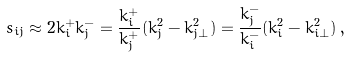<formula> <loc_0><loc_0><loc_500><loc_500>s _ { i j } \approx 2 k ^ { + } _ { i } k ^ { - } _ { j } = \frac { k ^ { + } _ { i } } { k ^ { + } _ { j } } ( k _ { j } ^ { 2 } - k ^ { 2 } _ { j \bot } ) = \frac { k ^ { - } _ { j } } { k ^ { - } _ { i } } ( k _ { i } ^ { 2 } - k ^ { 2 } _ { i \bot } ) \, ,</formula> 